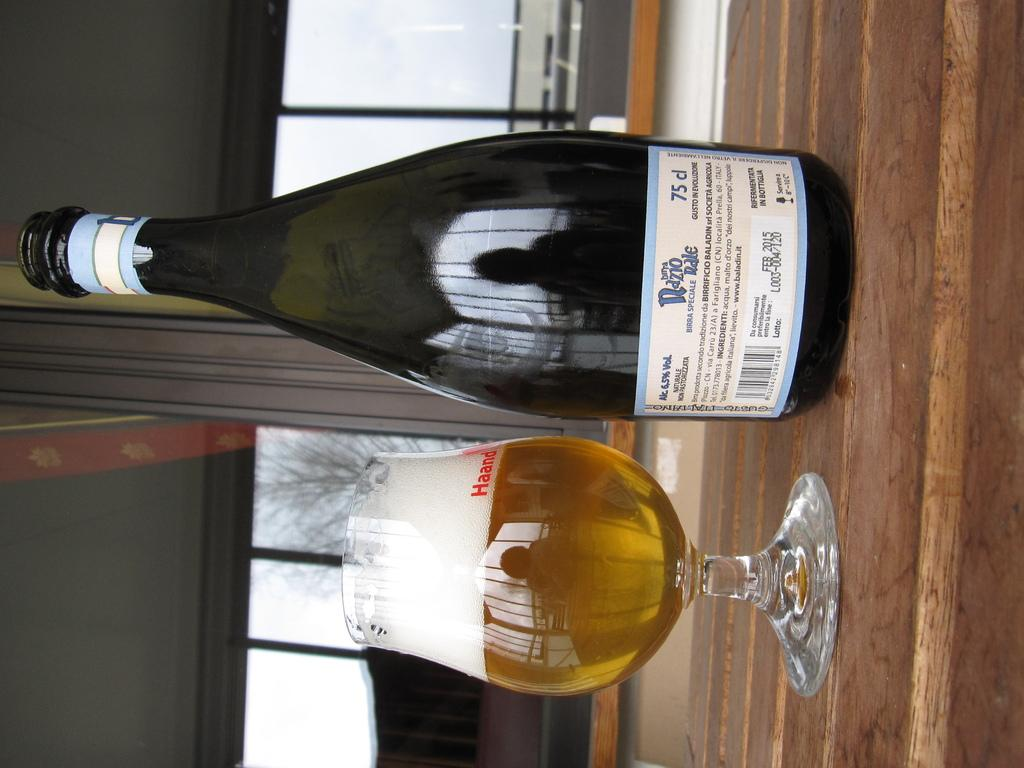What is present in the image that can hold a liquid? There is a bottle and a glass in the image. What is inside the glass in the image? The glass contains a drink. What can be seen in the background of the image? There is sky and trees visible in the background of the image. How many feet are visible in the image? There are no feet visible in the image. What type of prose can be read in the image? There is no prose present in the image. 